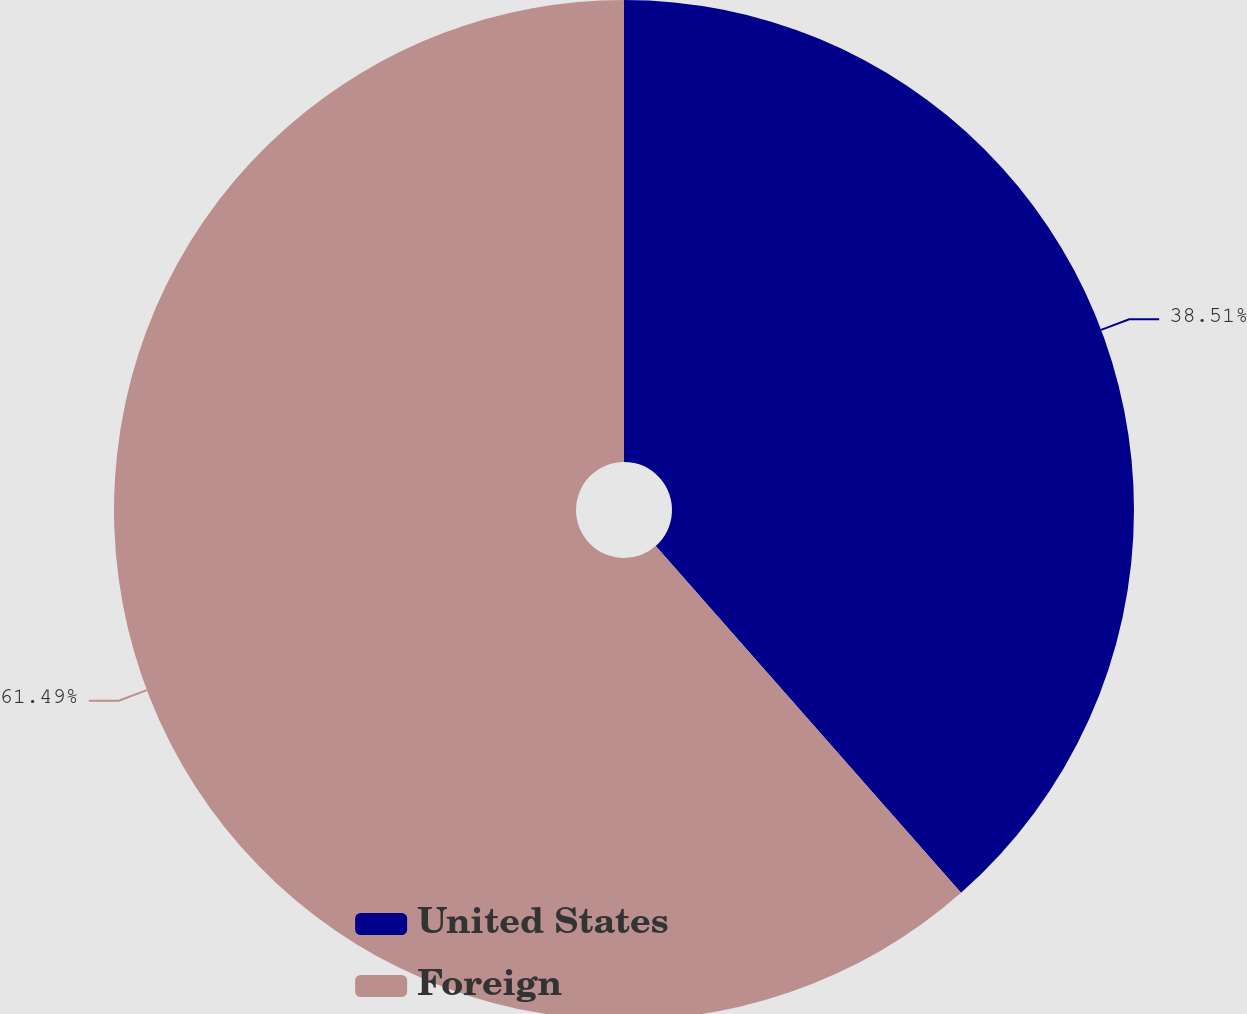<chart> <loc_0><loc_0><loc_500><loc_500><pie_chart><fcel>United States<fcel>Foreign<nl><fcel>38.51%<fcel>61.49%<nl></chart> 